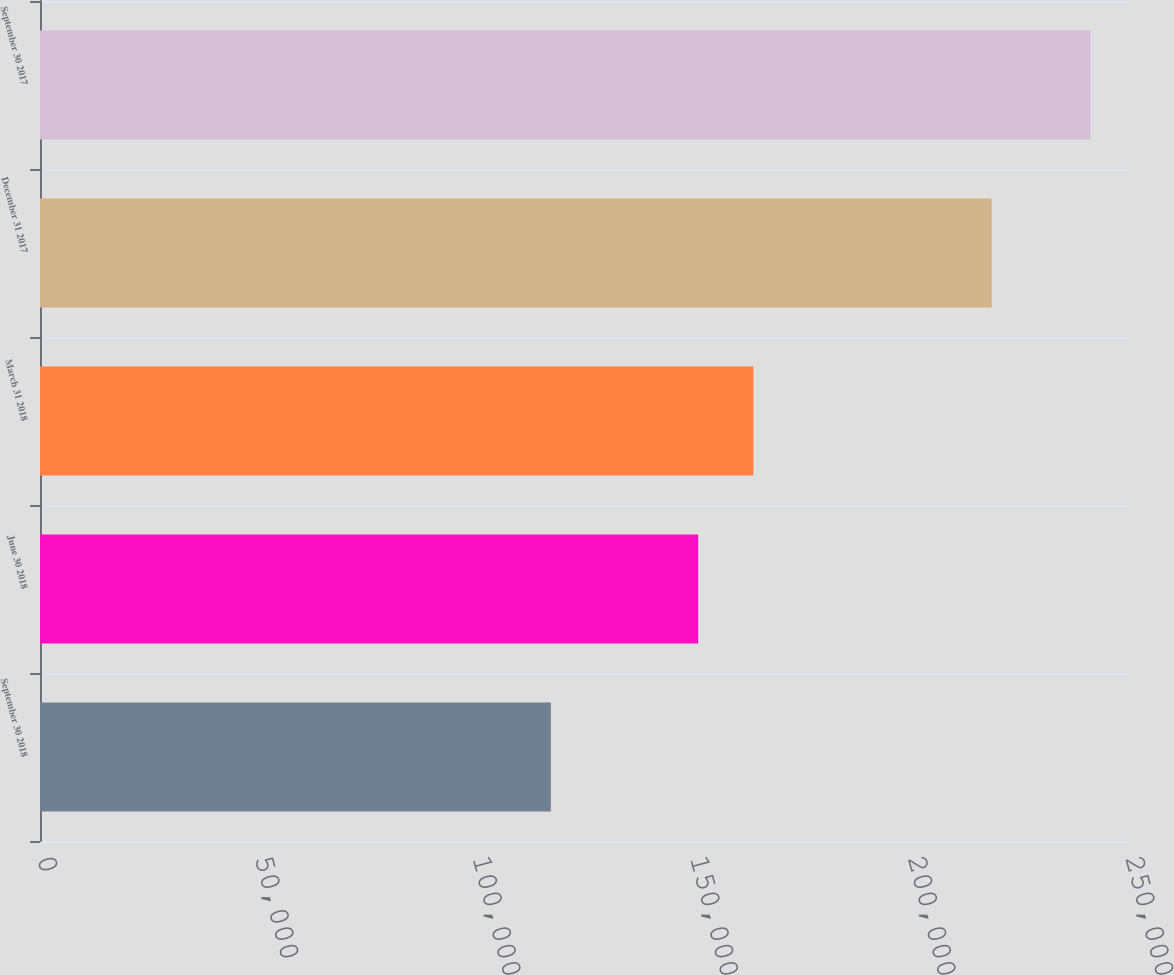Convert chart to OTSL. <chart><loc_0><loc_0><loc_500><loc_500><bar_chart><fcel>September 30 2018<fcel>June 30 2018<fcel>March 31 2018<fcel>December 31 2017<fcel>September 30 2017<nl><fcel>117388<fcel>151233<fcel>163923<fcel>218690<fcel>241365<nl></chart> 